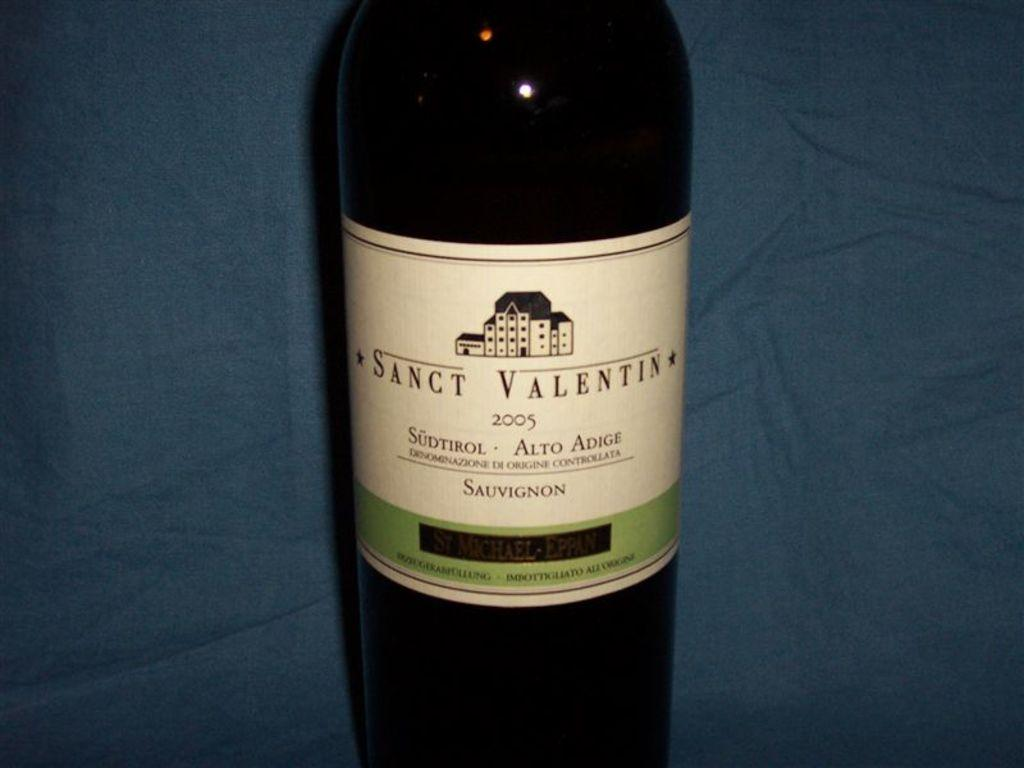<image>
Offer a succinct explanation of the picture presented. Bottle of wine with a label that says SANCT VALENTIN. 